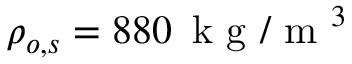Convert formula to latex. <formula><loc_0><loc_0><loc_500><loc_500>\rho _ { o , s } = 8 8 0 \, k g / m ^ { 3 }</formula> 